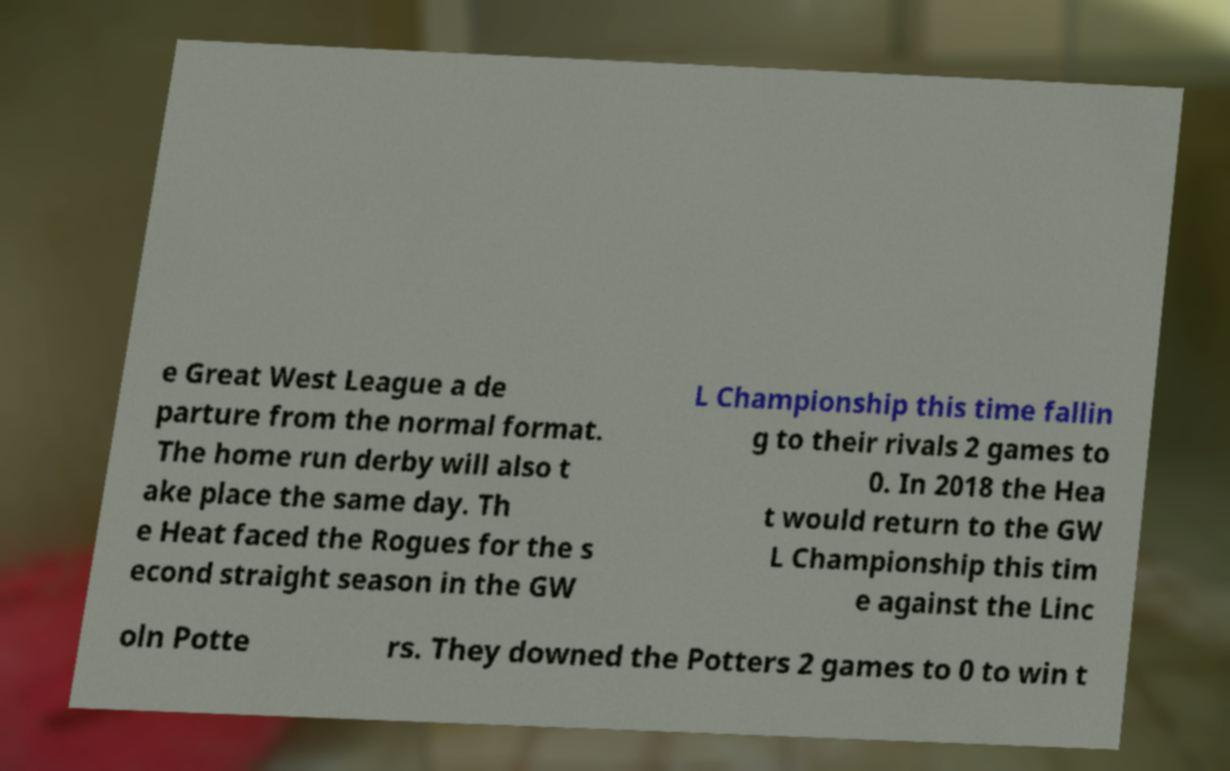Please identify and transcribe the text found in this image. e Great West League a de parture from the normal format. The home run derby will also t ake place the same day. Th e Heat faced the Rogues for the s econd straight season in the GW L Championship this time fallin g to their rivals 2 games to 0. In 2018 the Hea t would return to the GW L Championship this tim e against the Linc oln Potte rs. They downed the Potters 2 games to 0 to win t 